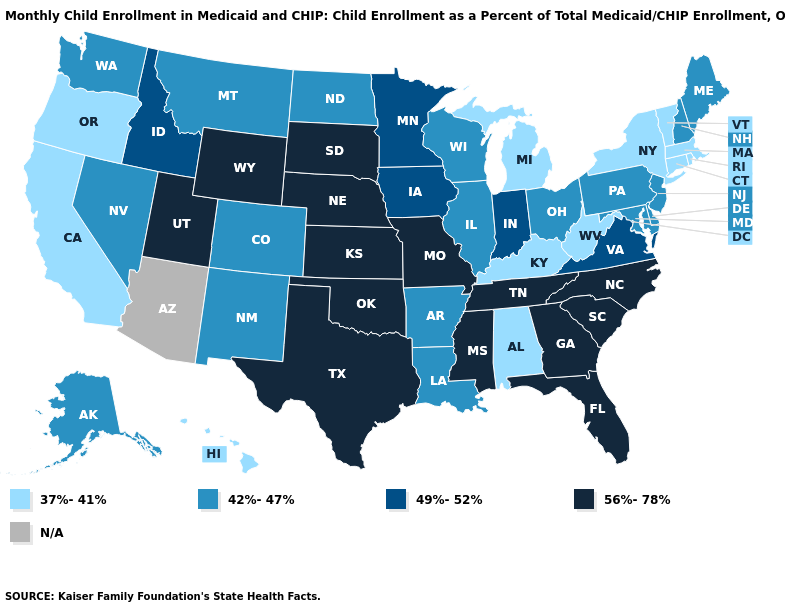Does South Carolina have the highest value in the USA?
Be succinct. Yes. Name the states that have a value in the range 56%-78%?
Be succinct. Florida, Georgia, Kansas, Mississippi, Missouri, Nebraska, North Carolina, Oklahoma, South Carolina, South Dakota, Tennessee, Texas, Utah, Wyoming. Name the states that have a value in the range 42%-47%?
Short answer required. Alaska, Arkansas, Colorado, Delaware, Illinois, Louisiana, Maine, Maryland, Montana, Nevada, New Hampshire, New Jersey, New Mexico, North Dakota, Ohio, Pennsylvania, Washington, Wisconsin. Which states have the lowest value in the West?
Write a very short answer. California, Hawaii, Oregon. What is the value of Alaska?
Concise answer only. 42%-47%. Name the states that have a value in the range 37%-41%?
Write a very short answer. Alabama, California, Connecticut, Hawaii, Kentucky, Massachusetts, Michigan, New York, Oregon, Rhode Island, Vermont, West Virginia. What is the lowest value in states that border Kentucky?
Write a very short answer. 37%-41%. What is the value of Illinois?
Concise answer only. 42%-47%. Among the states that border Colorado , which have the highest value?
Write a very short answer. Kansas, Nebraska, Oklahoma, Utah, Wyoming. Name the states that have a value in the range N/A?
Write a very short answer. Arizona. Name the states that have a value in the range 37%-41%?
Quick response, please. Alabama, California, Connecticut, Hawaii, Kentucky, Massachusetts, Michigan, New York, Oregon, Rhode Island, Vermont, West Virginia. What is the value of New Hampshire?
Quick response, please. 42%-47%. What is the value of Hawaii?
Give a very brief answer. 37%-41%. 